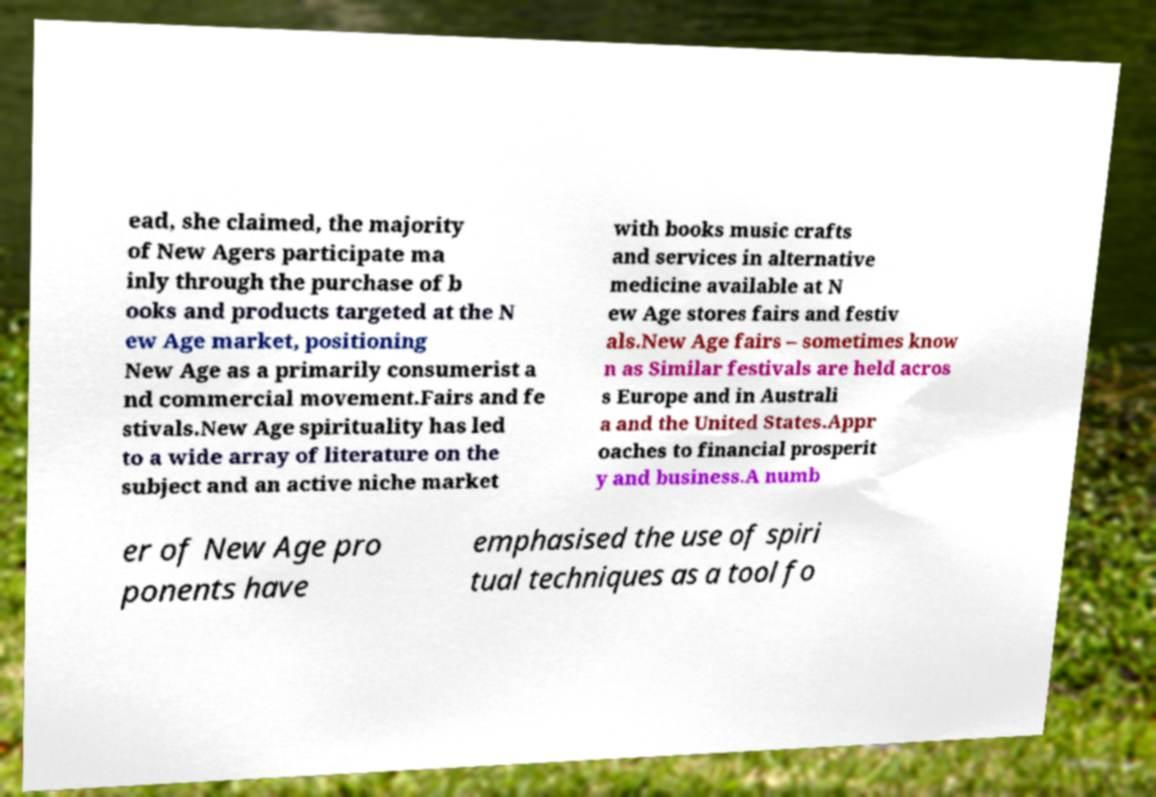Can you accurately transcribe the text from the provided image for me? ead, she claimed, the majority of New Agers participate ma inly through the purchase of b ooks and products targeted at the N ew Age market, positioning New Age as a primarily consumerist a nd commercial movement.Fairs and fe stivals.New Age spirituality has led to a wide array of literature on the subject and an active niche market with books music crafts and services in alternative medicine available at N ew Age stores fairs and festiv als.New Age fairs – sometimes know n as Similar festivals are held acros s Europe and in Australi a and the United States.Appr oaches to financial prosperit y and business.A numb er of New Age pro ponents have emphasised the use of spiri tual techniques as a tool fo 